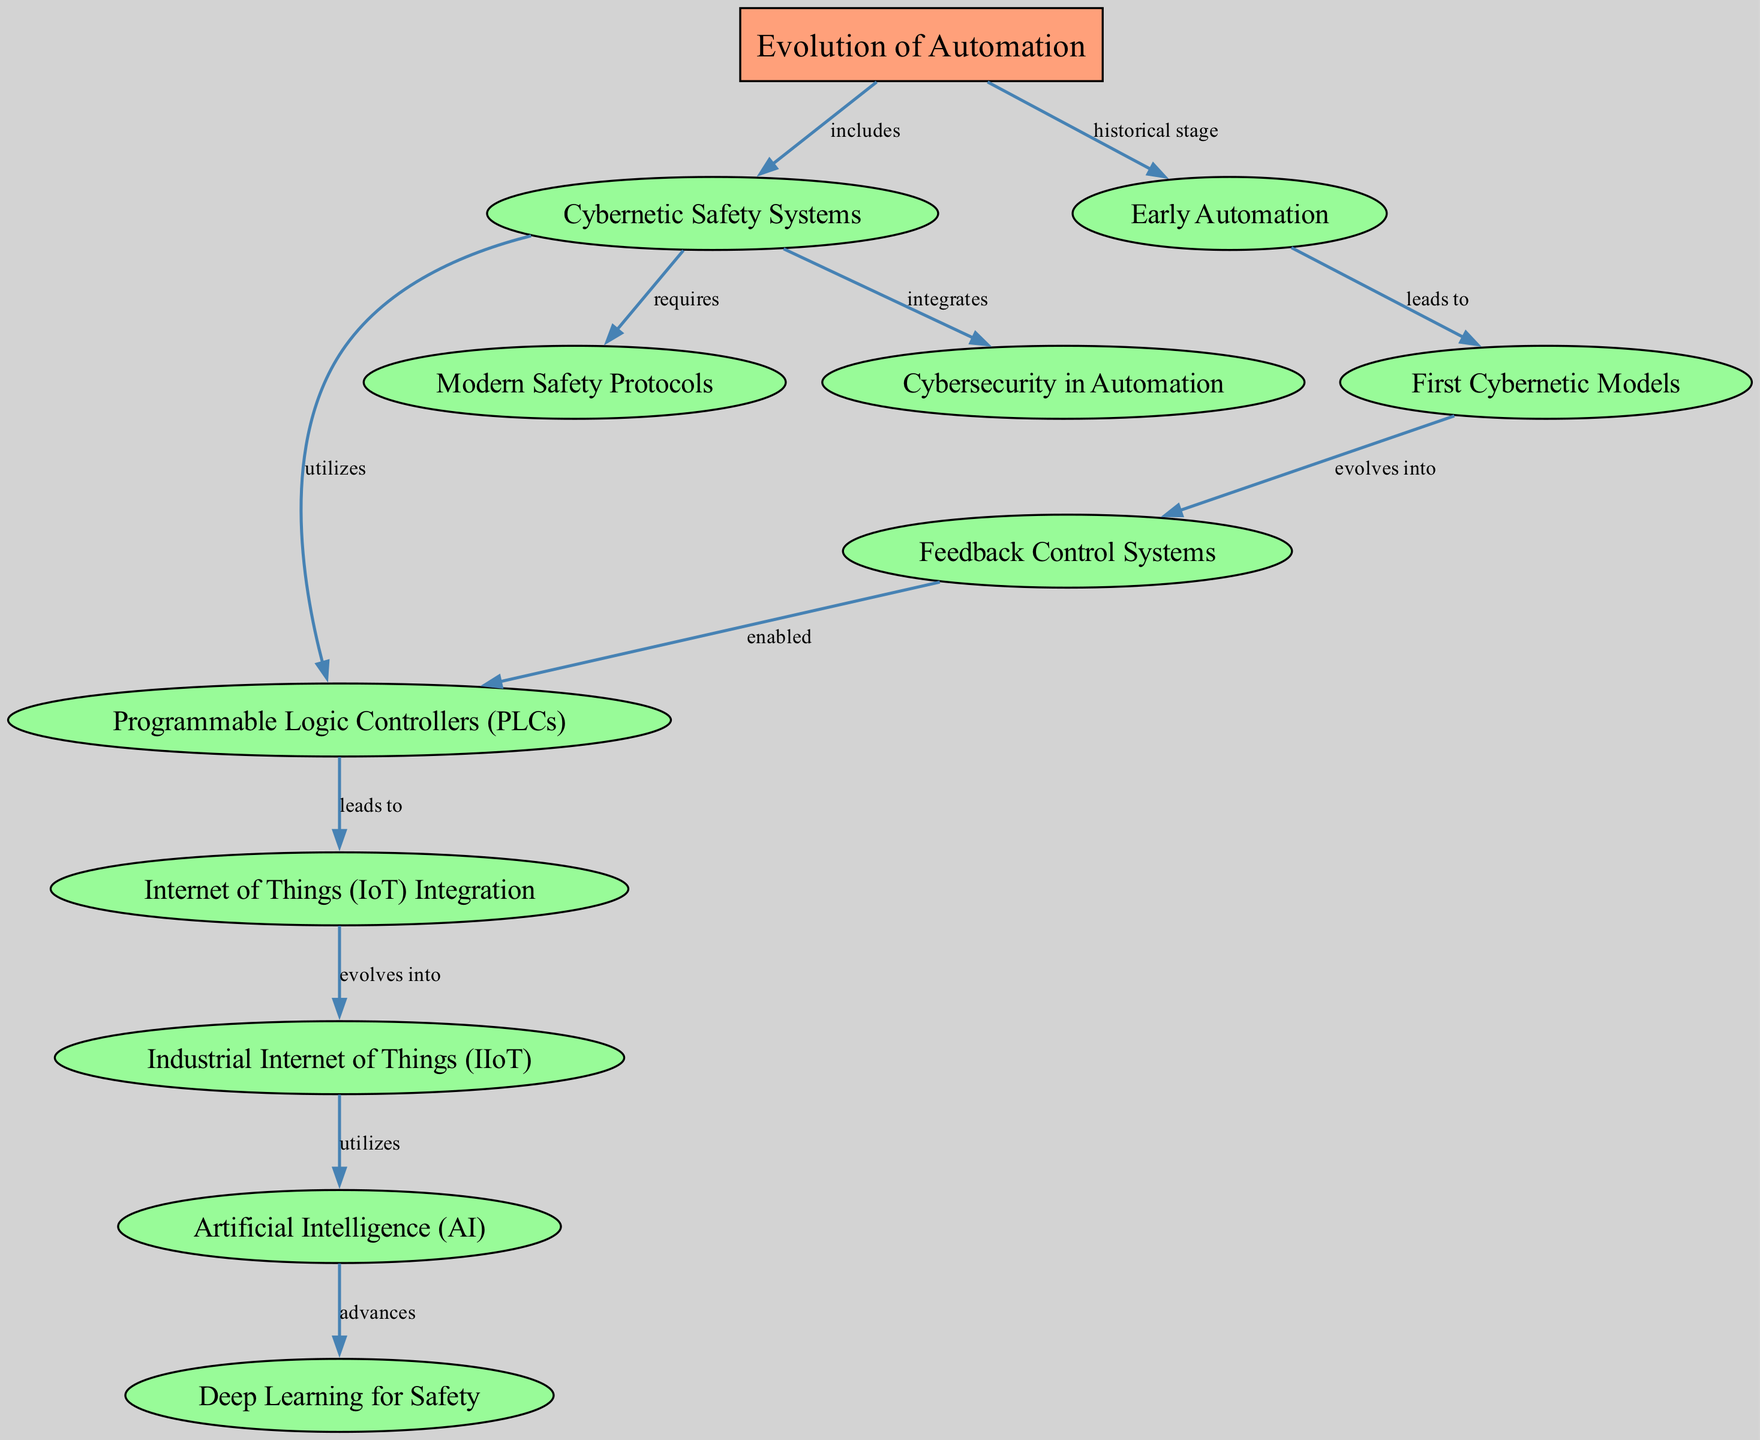What are the main topics in the diagram? The main topic is indicated at the top of the diagram with a label, which in this case is "Evolution of Automation". There is only one main topic in the diagram.
Answer: Evolution of Automation How many sub-topics are listed under the main topic? By analyzing the nodes, I count the number of sub-topics branching from the main topic. There are a total of ten sub-topics stemming from "Evolution of Automation".
Answer: 10 What is the relationship between "Early Automation" and "First Cybernetic Models"? The diagram shows a directional edge labeled "leads to" connecting "Early Automation" to "First Cybernetic Models". This means that the concept of Early Automation progresses to influence the development of First Cybernetic Models.
Answer: leads to Which sub-topic utilizes "Programmable Logic Controllers (PLCs)"? In the diagram, "Cybernetic Safety Systems" has a direct edge labeled "utilizes" that connects it to "Programmable Logic Controllers (PLCs)". This indicates that PLCs are an integral part of Cybernetic Safety Systems.
Answer: Cybernetic Safety Systems What evolves into "Industrial Internet of Things (IIoT)"? The edge labeled "evolves into" connects "Internet of Things (IoT) Integration" to "Industrial Internet of Things (IIoT)". This signifies a developmental progression, indicating that IoT Integration supports or transforms into IIoT.
Answer: Internet of Things (IoT) Integration How does "Artificial Intelligence (AI)" relate to "Deep Learning for Safety"? The connection between "Artificial Intelligence (AI)" and "Deep Learning for Safety" is described by the edge labeled "advances", indicating that AI contributes to the progression or enhancement of Deep Learning techniques used in safety applications.
Answer: advances Which node requires "Modern Safety Protocols"? The diagram indicates that "Cybernetic Safety Systems" has an edge labeled "requires" leading to "Modern Safety Protocols". This establishes that effective Cybernetic Safety Systems depend on implementing these protocols.
Answer: Cybernetic Safety Systems What is the relationship between "Feedback Control Systems" and "Programmable Logic Controllers (PLCs)"? "Feedback Control Systems" enables the creation of "Programmable Logic Controllers (PLCs)", as represented by the edge labeled "enabled" in the diagram. This shows a foundational role for feedback systems in the development of programmable controllers.
Answer: enabled Which sub-topic is directly linked to "Cybersecurity in Automation"? The edge labeled "integrates" connects "Cybernetic Safety Systems" to "Cybersecurity in Automation", signifying that effective safety systems must incorporate cybersecurity measures.
Answer: Cybernetic Safety Systems 